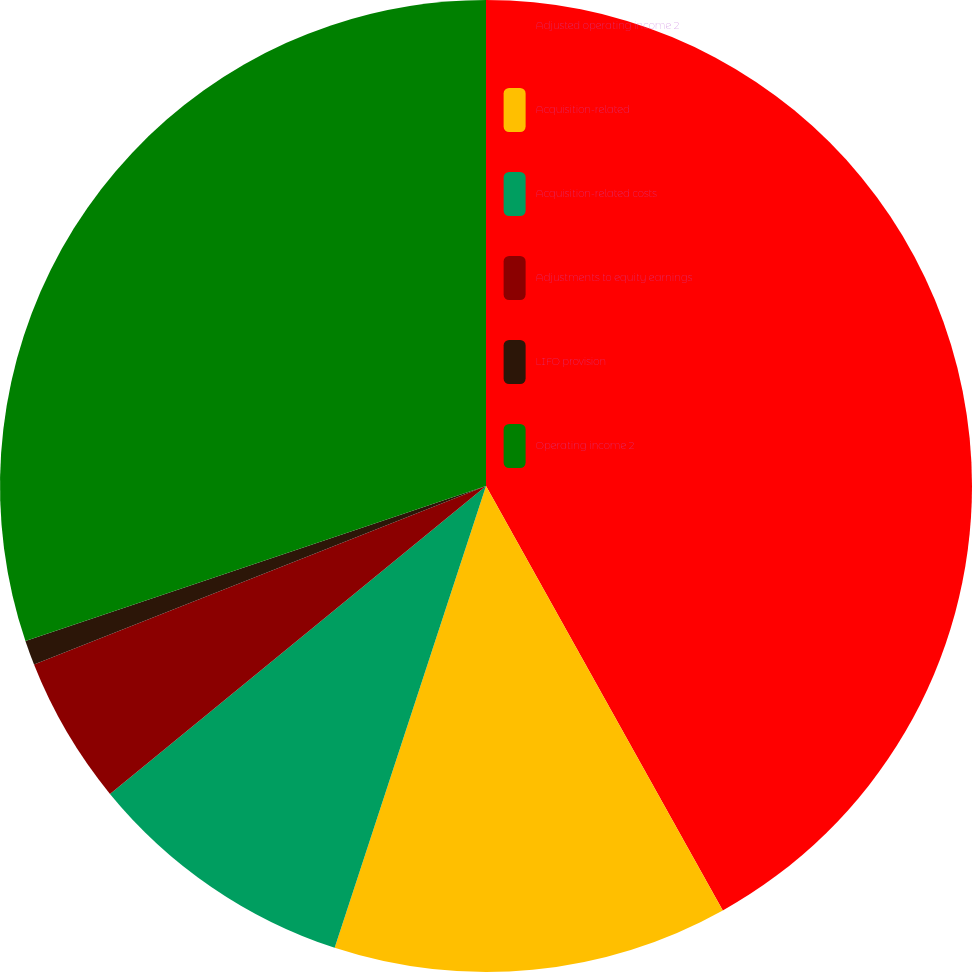Convert chart to OTSL. <chart><loc_0><loc_0><loc_500><loc_500><pie_chart><fcel>Adjusted operating income 2<fcel>Acquisition-related<fcel>Acquisition-related costs<fcel>Adjustments to equity earnings<fcel>LIFO provision<fcel>Operating income 2<nl><fcel>41.9%<fcel>13.14%<fcel>9.04%<fcel>4.93%<fcel>0.82%<fcel>30.17%<nl></chart> 